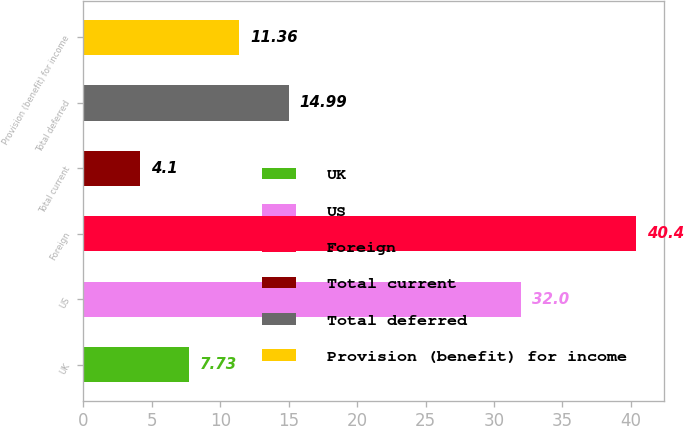Convert chart to OTSL. <chart><loc_0><loc_0><loc_500><loc_500><bar_chart><fcel>UK<fcel>US<fcel>Foreign<fcel>Total current<fcel>Total deferred<fcel>Provision (benefit) for income<nl><fcel>7.73<fcel>32<fcel>40.4<fcel>4.1<fcel>14.99<fcel>11.36<nl></chart> 